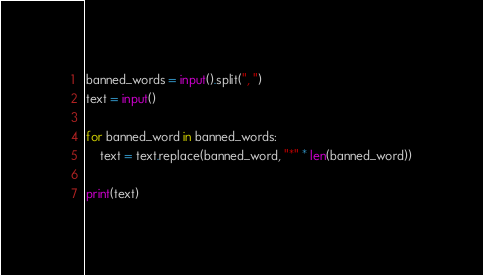<code> <loc_0><loc_0><loc_500><loc_500><_Python_>banned_words = input().split(", ")
text = input()

for banned_word in banned_words:
    text = text.replace(banned_word, "*" * len(banned_word))

print(text)</code> 